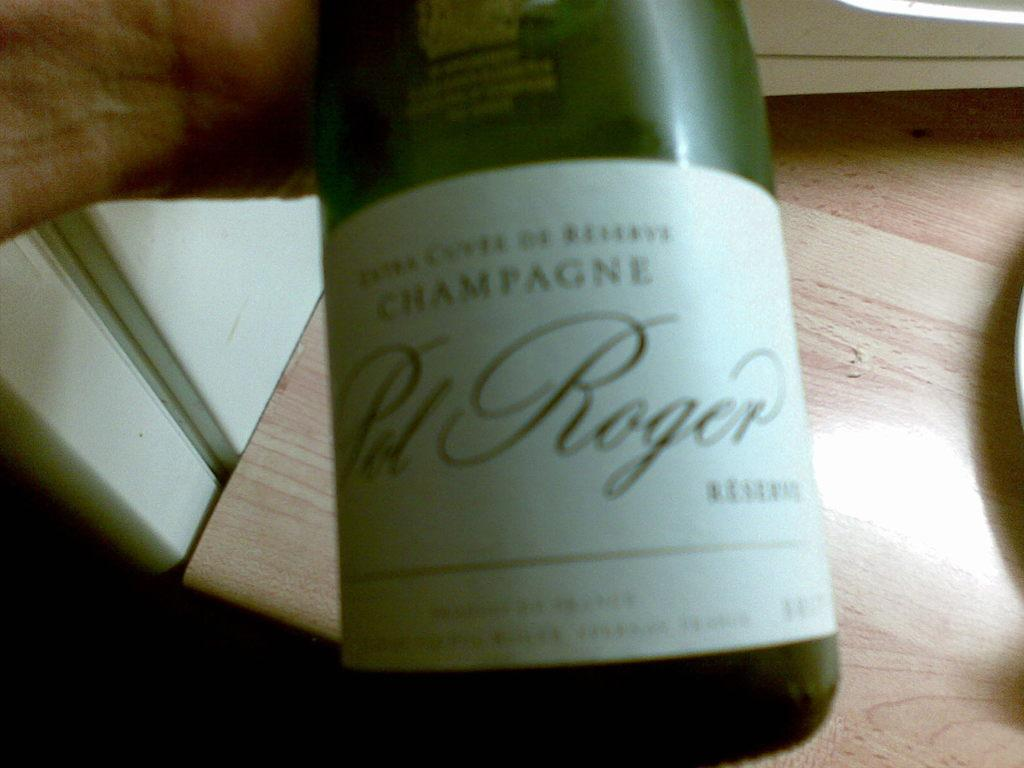What object can be seen in the image? There is a bottle in the image. Can you see a bat flying around the bottle in the image? There is no bat present in the image; it only features a bottle. What type of boundary is visible around the bottle in the image? There is no boundary visible around the bottle in the image; it is a standalone object. 